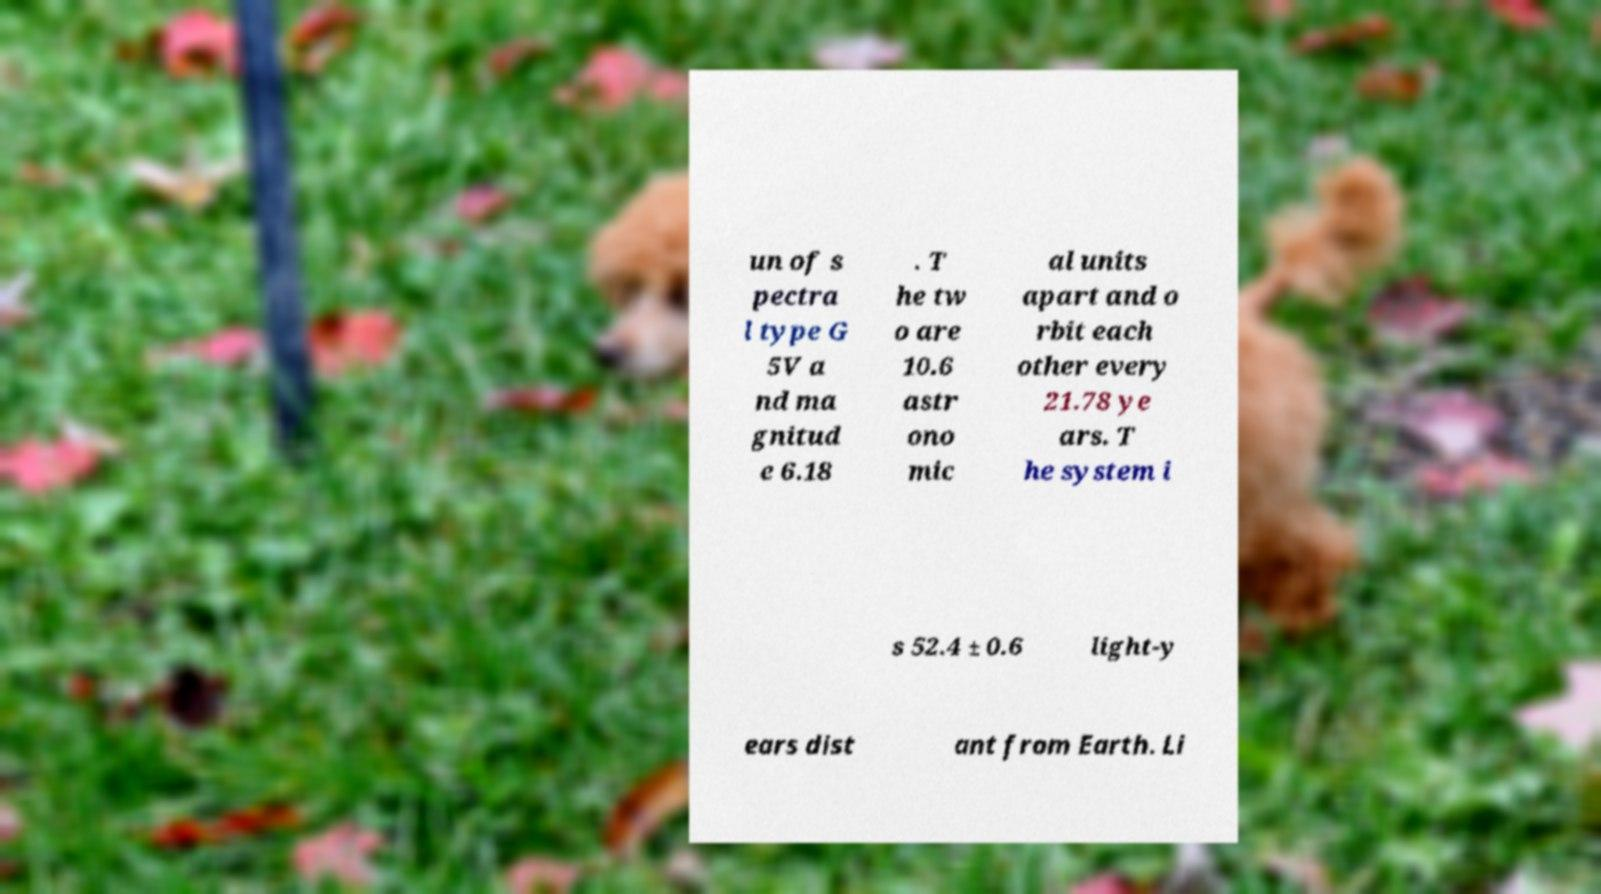There's text embedded in this image that I need extracted. Can you transcribe it verbatim? un of s pectra l type G 5V a nd ma gnitud e 6.18 . T he tw o are 10.6 astr ono mic al units apart and o rbit each other every 21.78 ye ars. T he system i s 52.4 ± 0.6 light-y ears dist ant from Earth. Li 